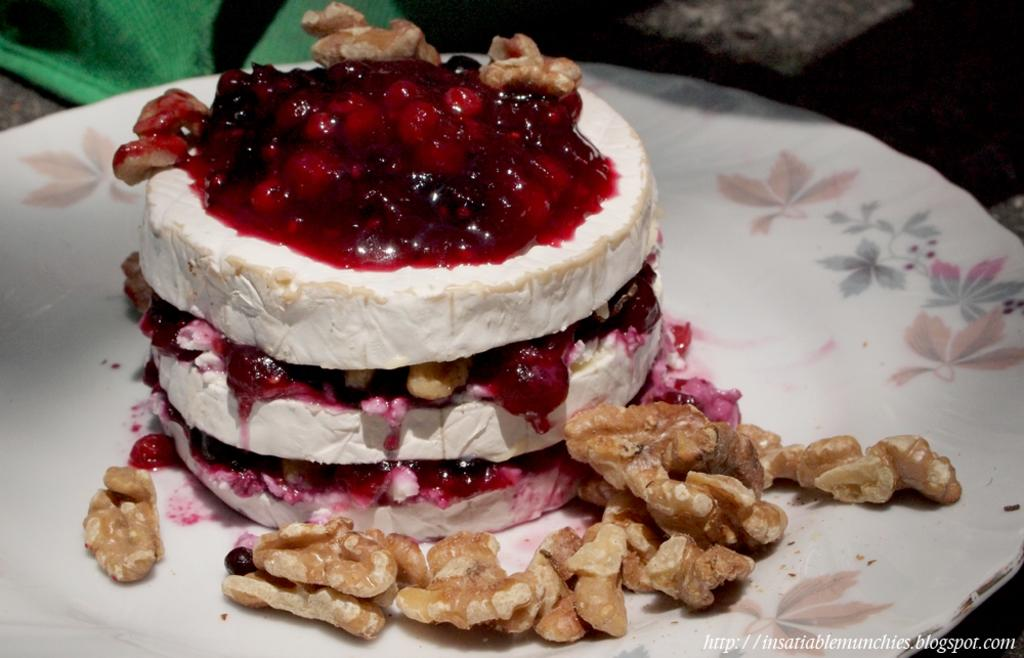What type of food item is present in the image? There is a food item in the image that resembles a cake. What is on top of the cake? The cake has nuts on it. Where is the cake placed? The cake is on a plate. What can be seen at the top of the image? There are objects visible at the top of the image. What is the route of the song that is being sung in the image? There is no song or route present in the image; it features a cake with nuts on it. What type of cloud is visible in the image? There is no cloud visible in the image; it only shows a cake with nuts on it. 